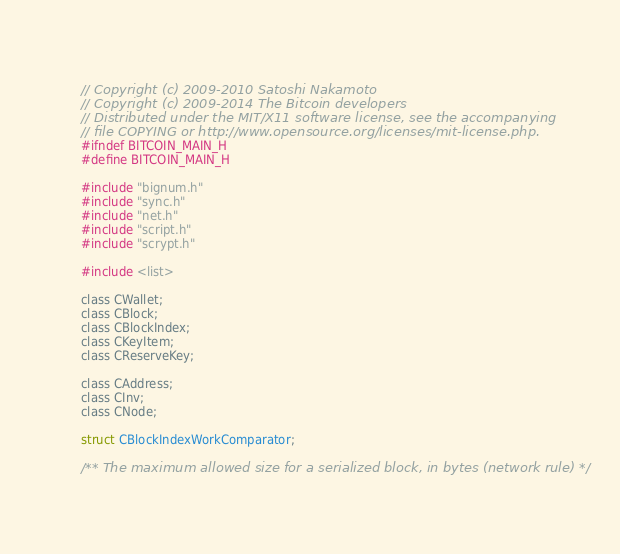<code> <loc_0><loc_0><loc_500><loc_500><_C_>// Copyright (c) 2009-2010 Satoshi Nakamoto
// Copyright (c) 2009-2014 The Bitcoin developers
// Distributed under the MIT/X11 software license, see the accompanying
// file COPYING or http://www.opensource.org/licenses/mit-license.php.
#ifndef BITCOIN_MAIN_H
#define BITCOIN_MAIN_H

#include "bignum.h"
#include "sync.h"
#include "net.h"
#include "script.h"
#include "scrypt.h"

#include <list>

class CWallet;
class CBlock;
class CBlockIndex;
class CKeyItem;
class CReserveKey;

class CAddress;
class CInv;
class CNode;

struct CBlockIndexWorkComparator;

/** The maximum allowed size for a serialized block, in bytes (network rule) */</code> 